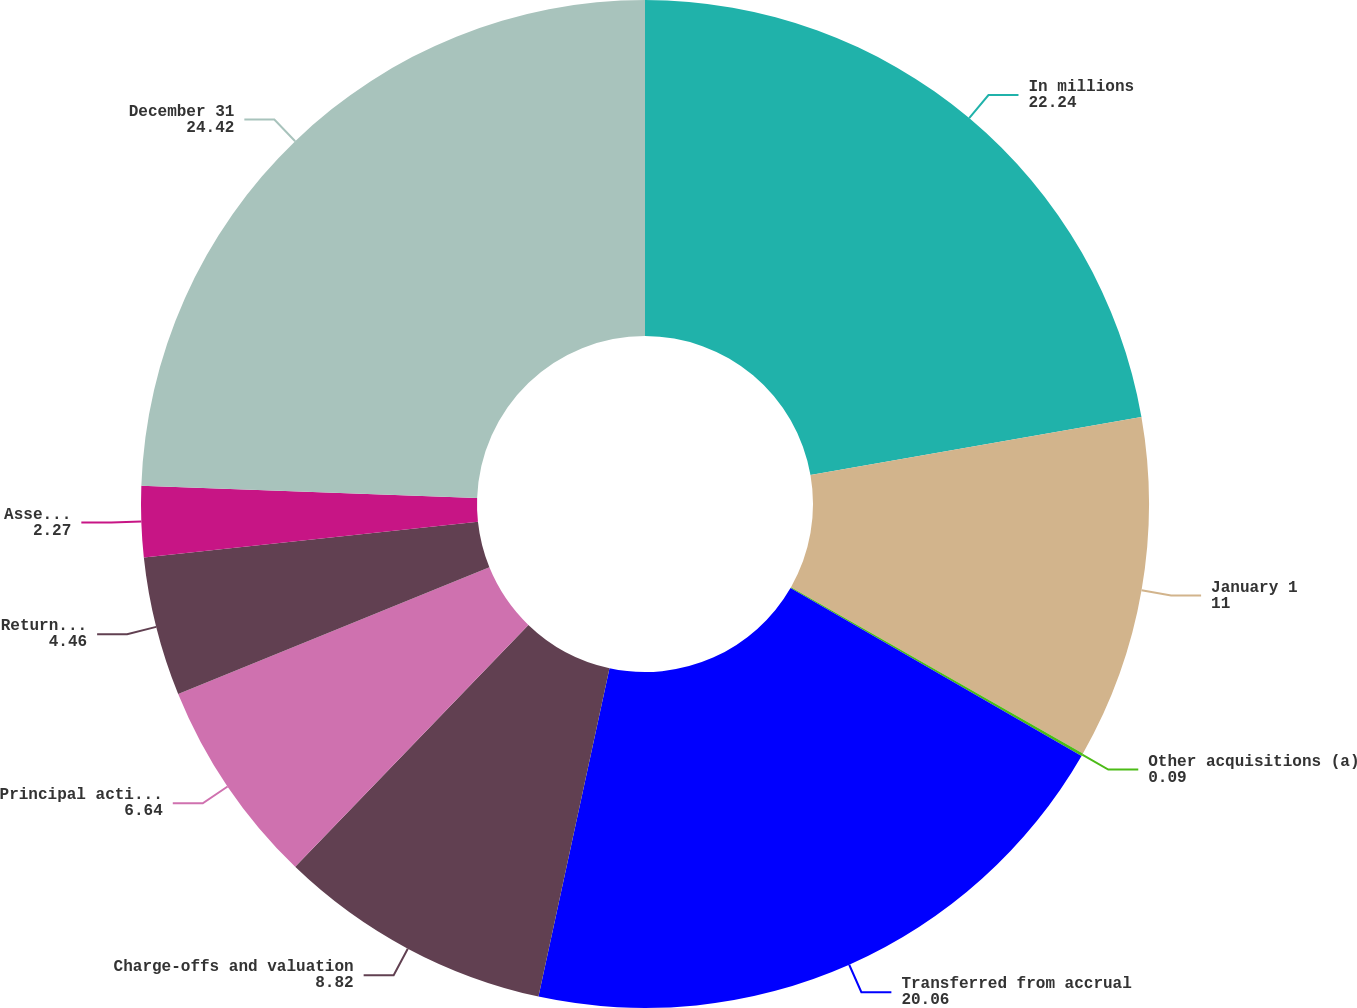Convert chart to OTSL. <chart><loc_0><loc_0><loc_500><loc_500><pie_chart><fcel>In millions<fcel>January 1<fcel>Other acquisitions (a)<fcel>Transferred from accrual<fcel>Charge-offs and valuation<fcel>Principal activity including<fcel>Returned to performing<fcel>Asset sales<fcel>December 31<nl><fcel>22.24%<fcel>11.0%<fcel>0.09%<fcel>20.06%<fcel>8.82%<fcel>6.64%<fcel>4.46%<fcel>2.27%<fcel>24.42%<nl></chart> 